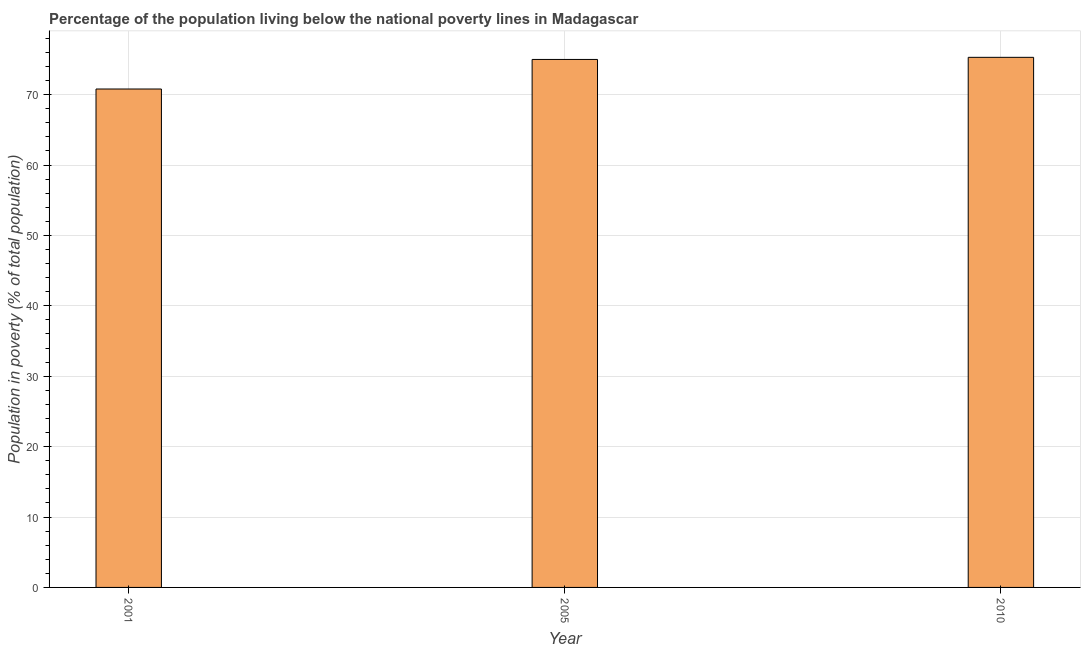What is the title of the graph?
Your answer should be very brief. Percentage of the population living below the national poverty lines in Madagascar. What is the label or title of the X-axis?
Keep it short and to the point. Year. What is the label or title of the Y-axis?
Your answer should be compact. Population in poverty (% of total population). What is the percentage of population living below poverty line in 2001?
Make the answer very short. 70.8. Across all years, what is the maximum percentage of population living below poverty line?
Give a very brief answer. 75.3. Across all years, what is the minimum percentage of population living below poverty line?
Make the answer very short. 70.8. What is the sum of the percentage of population living below poverty line?
Make the answer very short. 221.1. What is the average percentage of population living below poverty line per year?
Provide a succinct answer. 73.7. Is the percentage of population living below poverty line in 2005 less than that in 2010?
Your response must be concise. Yes. Is the difference between the percentage of population living below poverty line in 2005 and 2010 greater than the difference between any two years?
Ensure brevity in your answer.  No. What is the difference between the highest and the second highest percentage of population living below poverty line?
Your answer should be compact. 0.3. What is the difference between the highest and the lowest percentage of population living below poverty line?
Offer a very short reply. 4.5. How many bars are there?
Your response must be concise. 3. Are all the bars in the graph horizontal?
Ensure brevity in your answer.  No. What is the difference between two consecutive major ticks on the Y-axis?
Your answer should be compact. 10. What is the Population in poverty (% of total population) of 2001?
Make the answer very short. 70.8. What is the Population in poverty (% of total population) of 2005?
Give a very brief answer. 75. What is the Population in poverty (% of total population) in 2010?
Make the answer very short. 75.3. What is the difference between the Population in poverty (% of total population) in 2005 and 2010?
Provide a succinct answer. -0.3. What is the ratio of the Population in poverty (% of total population) in 2001 to that in 2005?
Provide a succinct answer. 0.94. What is the ratio of the Population in poverty (% of total population) in 2001 to that in 2010?
Give a very brief answer. 0.94. What is the ratio of the Population in poverty (% of total population) in 2005 to that in 2010?
Offer a very short reply. 1. 